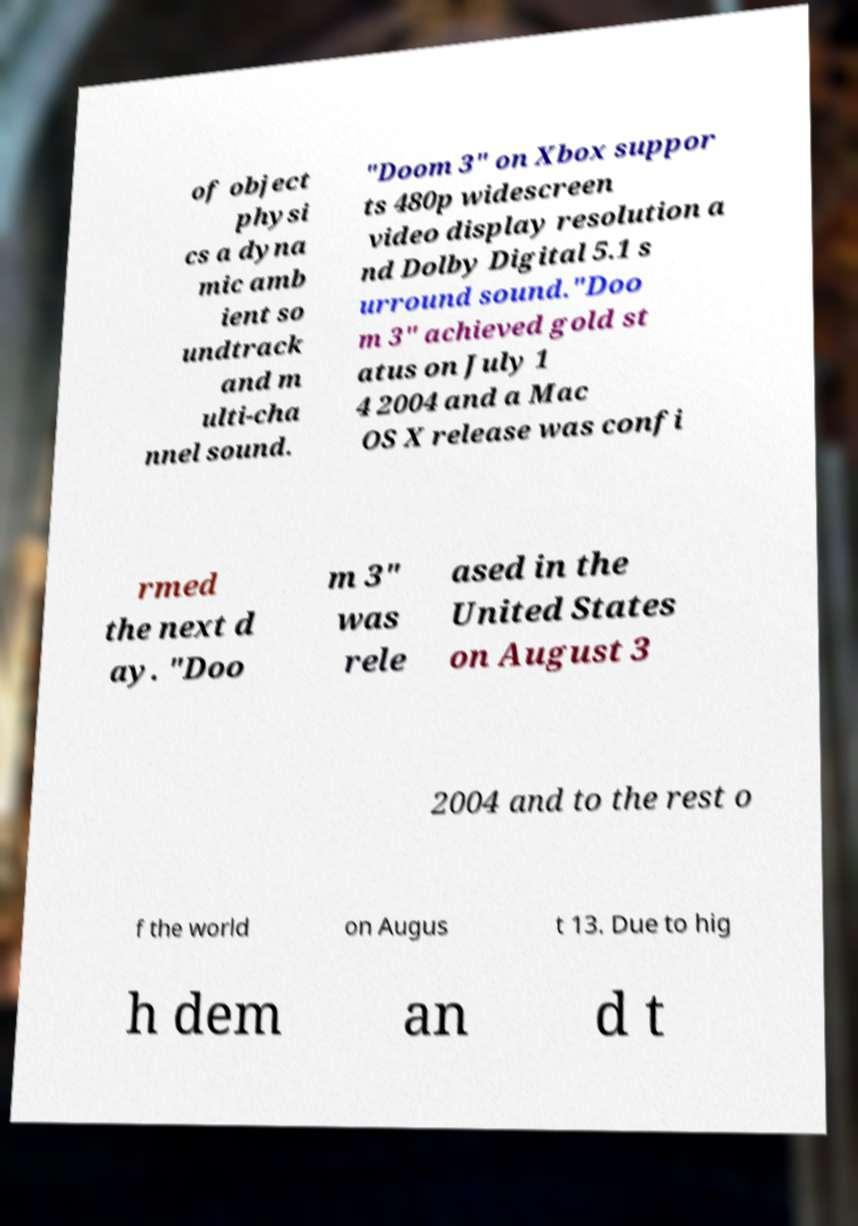Could you extract and type out the text from this image? of object physi cs a dyna mic amb ient so undtrack and m ulti-cha nnel sound. "Doom 3" on Xbox suppor ts 480p widescreen video display resolution a nd Dolby Digital 5.1 s urround sound."Doo m 3" achieved gold st atus on July 1 4 2004 and a Mac OS X release was confi rmed the next d ay. "Doo m 3" was rele ased in the United States on August 3 2004 and to the rest o f the world on Augus t 13. Due to hig h dem an d t 